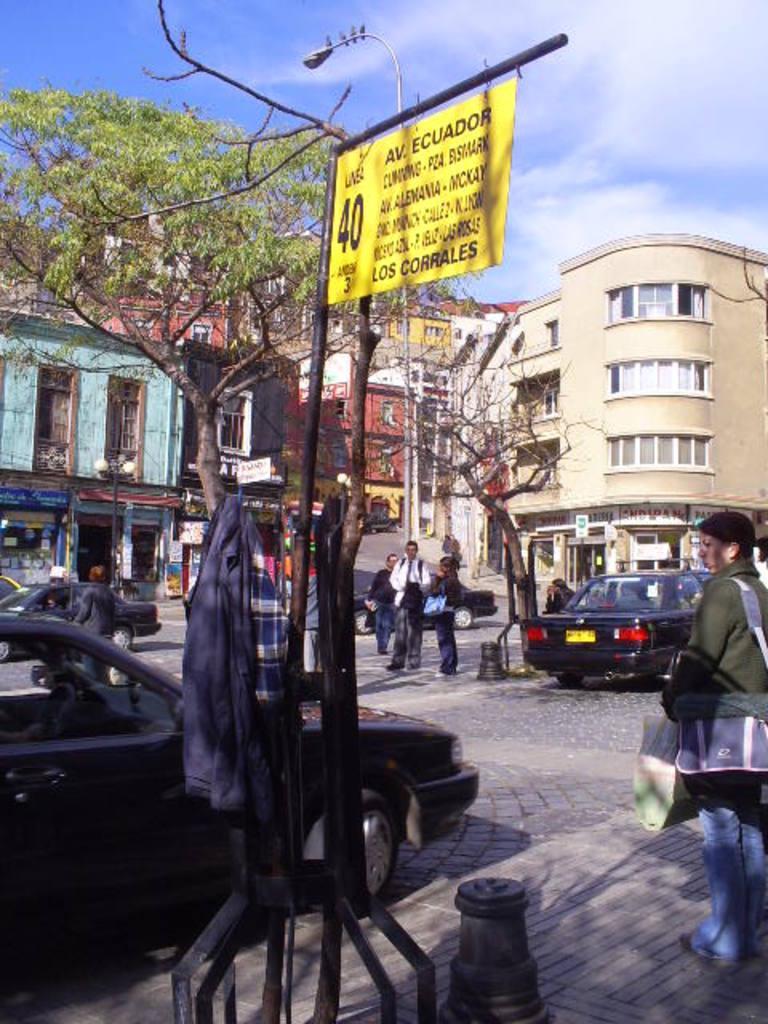How would you summarize this image in a sentence or two? In this picture we can observe yellow color board fixed to this black color pole. There are some clothes hanged here. We can observe a black color car. There are some people standing. On the right side there is a woman holding bags. In the background there is a dried tree and some buildings. We can observe a sky with clouds. 